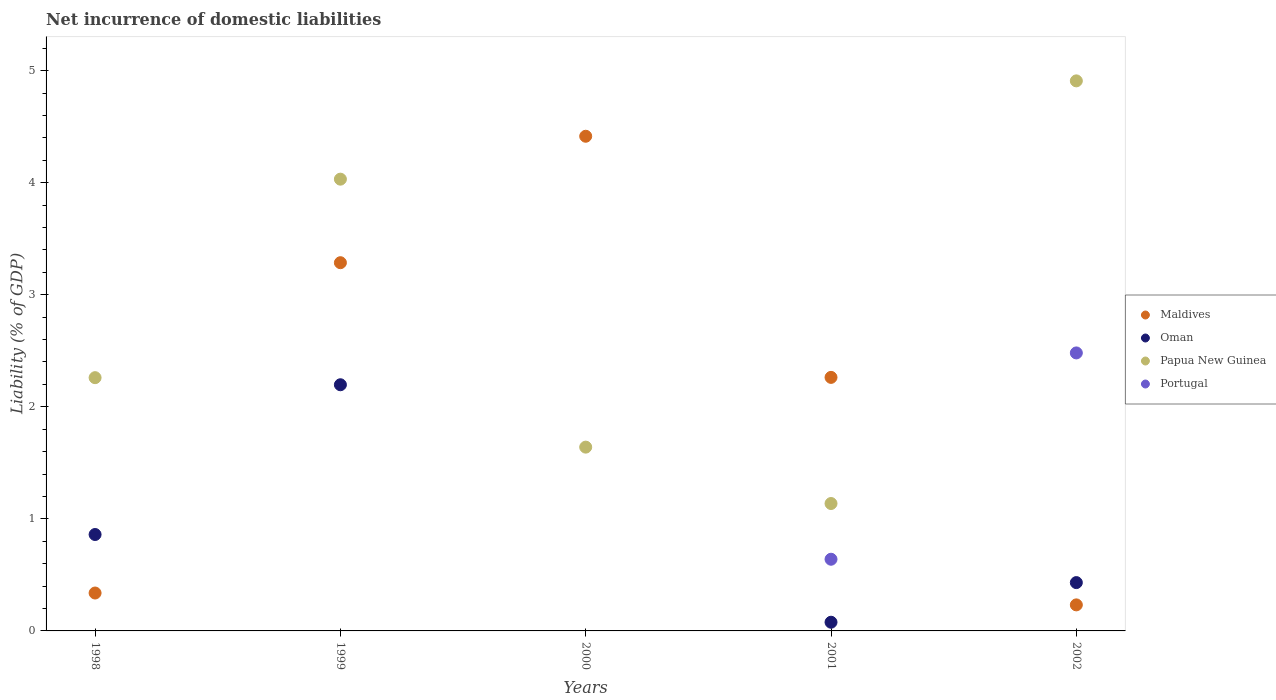How many different coloured dotlines are there?
Make the answer very short. 4. Across all years, what is the maximum net incurrence of domestic liabilities in Papua New Guinea?
Offer a very short reply. 4.91. Across all years, what is the minimum net incurrence of domestic liabilities in Papua New Guinea?
Ensure brevity in your answer.  1.14. In which year was the net incurrence of domestic liabilities in Maldives maximum?
Offer a terse response. 2000. What is the total net incurrence of domestic liabilities in Maldives in the graph?
Keep it short and to the point. 10.53. What is the difference between the net incurrence of domestic liabilities in Maldives in 2000 and that in 2002?
Offer a terse response. 4.18. What is the difference between the net incurrence of domestic liabilities in Papua New Guinea in 2002 and the net incurrence of domestic liabilities in Portugal in 2001?
Provide a short and direct response. 4.27. What is the average net incurrence of domestic liabilities in Maldives per year?
Offer a terse response. 2.11. In the year 2001, what is the difference between the net incurrence of domestic liabilities in Portugal and net incurrence of domestic liabilities in Oman?
Keep it short and to the point. 0.56. In how many years, is the net incurrence of domestic liabilities in Papua New Guinea greater than 4.8 %?
Your response must be concise. 1. What is the ratio of the net incurrence of domestic liabilities in Maldives in 1998 to that in 2000?
Provide a short and direct response. 0.08. Is the net incurrence of domestic liabilities in Oman in 1998 less than that in 2002?
Provide a short and direct response. No. What is the difference between the highest and the second highest net incurrence of domestic liabilities in Oman?
Your response must be concise. 1.34. What is the difference between the highest and the lowest net incurrence of domestic liabilities in Maldives?
Provide a succinct answer. 4.18. In how many years, is the net incurrence of domestic liabilities in Portugal greater than the average net incurrence of domestic liabilities in Portugal taken over all years?
Your response must be concise. 2. Does the net incurrence of domestic liabilities in Portugal monotonically increase over the years?
Offer a terse response. No. Does the graph contain any zero values?
Your answer should be very brief. Yes. How many legend labels are there?
Your answer should be very brief. 4. What is the title of the graph?
Provide a short and direct response. Net incurrence of domestic liabilities. Does "Chad" appear as one of the legend labels in the graph?
Your answer should be very brief. No. What is the label or title of the Y-axis?
Provide a short and direct response. Liability (% of GDP). What is the Liability (% of GDP) of Maldives in 1998?
Your answer should be very brief. 0.34. What is the Liability (% of GDP) of Oman in 1998?
Your answer should be compact. 0.86. What is the Liability (% of GDP) in Papua New Guinea in 1998?
Make the answer very short. 2.26. What is the Liability (% of GDP) of Maldives in 1999?
Ensure brevity in your answer.  3.29. What is the Liability (% of GDP) in Oman in 1999?
Give a very brief answer. 2.2. What is the Liability (% of GDP) of Papua New Guinea in 1999?
Make the answer very short. 4.03. What is the Liability (% of GDP) of Portugal in 1999?
Keep it short and to the point. 0. What is the Liability (% of GDP) in Maldives in 2000?
Your answer should be compact. 4.41. What is the Liability (% of GDP) of Papua New Guinea in 2000?
Keep it short and to the point. 1.64. What is the Liability (% of GDP) in Portugal in 2000?
Keep it short and to the point. 0. What is the Liability (% of GDP) of Maldives in 2001?
Your response must be concise. 2.26. What is the Liability (% of GDP) of Oman in 2001?
Your response must be concise. 0.08. What is the Liability (% of GDP) of Papua New Guinea in 2001?
Provide a succinct answer. 1.14. What is the Liability (% of GDP) in Portugal in 2001?
Your answer should be very brief. 0.64. What is the Liability (% of GDP) of Maldives in 2002?
Provide a short and direct response. 0.23. What is the Liability (% of GDP) in Oman in 2002?
Offer a very short reply. 0.43. What is the Liability (% of GDP) of Papua New Guinea in 2002?
Offer a very short reply. 4.91. What is the Liability (% of GDP) of Portugal in 2002?
Ensure brevity in your answer.  2.48. Across all years, what is the maximum Liability (% of GDP) of Maldives?
Make the answer very short. 4.41. Across all years, what is the maximum Liability (% of GDP) of Oman?
Your answer should be compact. 2.2. Across all years, what is the maximum Liability (% of GDP) of Papua New Guinea?
Keep it short and to the point. 4.91. Across all years, what is the maximum Liability (% of GDP) of Portugal?
Ensure brevity in your answer.  2.48. Across all years, what is the minimum Liability (% of GDP) in Maldives?
Your answer should be compact. 0.23. Across all years, what is the minimum Liability (% of GDP) of Papua New Guinea?
Your answer should be compact. 1.14. Across all years, what is the minimum Liability (% of GDP) of Portugal?
Your answer should be compact. 0. What is the total Liability (% of GDP) of Maldives in the graph?
Ensure brevity in your answer.  10.53. What is the total Liability (% of GDP) in Oman in the graph?
Give a very brief answer. 3.57. What is the total Liability (% of GDP) of Papua New Guinea in the graph?
Offer a very short reply. 13.98. What is the total Liability (% of GDP) in Portugal in the graph?
Ensure brevity in your answer.  3.12. What is the difference between the Liability (% of GDP) of Maldives in 1998 and that in 1999?
Your answer should be very brief. -2.95. What is the difference between the Liability (% of GDP) of Oman in 1998 and that in 1999?
Provide a succinct answer. -1.34. What is the difference between the Liability (% of GDP) of Papua New Guinea in 1998 and that in 1999?
Offer a very short reply. -1.77. What is the difference between the Liability (% of GDP) in Maldives in 1998 and that in 2000?
Make the answer very short. -4.08. What is the difference between the Liability (% of GDP) in Papua New Guinea in 1998 and that in 2000?
Make the answer very short. 0.62. What is the difference between the Liability (% of GDP) in Maldives in 1998 and that in 2001?
Your answer should be compact. -1.92. What is the difference between the Liability (% of GDP) in Oman in 1998 and that in 2001?
Offer a very short reply. 0.78. What is the difference between the Liability (% of GDP) of Papua New Guinea in 1998 and that in 2001?
Ensure brevity in your answer.  1.12. What is the difference between the Liability (% of GDP) in Maldives in 1998 and that in 2002?
Offer a very short reply. 0.11. What is the difference between the Liability (% of GDP) of Oman in 1998 and that in 2002?
Your response must be concise. 0.43. What is the difference between the Liability (% of GDP) in Papua New Guinea in 1998 and that in 2002?
Make the answer very short. -2.65. What is the difference between the Liability (% of GDP) in Maldives in 1999 and that in 2000?
Offer a terse response. -1.13. What is the difference between the Liability (% of GDP) in Papua New Guinea in 1999 and that in 2000?
Offer a terse response. 2.39. What is the difference between the Liability (% of GDP) in Maldives in 1999 and that in 2001?
Ensure brevity in your answer.  1.02. What is the difference between the Liability (% of GDP) of Oman in 1999 and that in 2001?
Ensure brevity in your answer.  2.12. What is the difference between the Liability (% of GDP) in Papua New Guinea in 1999 and that in 2001?
Provide a short and direct response. 2.89. What is the difference between the Liability (% of GDP) in Maldives in 1999 and that in 2002?
Make the answer very short. 3.05. What is the difference between the Liability (% of GDP) of Oman in 1999 and that in 2002?
Offer a very short reply. 1.77. What is the difference between the Liability (% of GDP) in Papua New Guinea in 1999 and that in 2002?
Provide a short and direct response. -0.88. What is the difference between the Liability (% of GDP) in Maldives in 2000 and that in 2001?
Offer a very short reply. 2.15. What is the difference between the Liability (% of GDP) in Papua New Guinea in 2000 and that in 2001?
Make the answer very short. 0.5. What is the difference between the Liability (% of GDP) of Maldives in 2000 and that in 2002?
Your answer should be very brief. 4.18. What is the difference between the Liability (% of GDP) in Papua New Guinea in 2000 and that in 2002?
Ensure brevity in your answer.  -3.27. What is the difference between the Liability (% of GDP) of Maldives in 2001 and that in 2002?
Your response must be concise. 2.03. What is the difference between the Liability (% of GDP) of Oman in 2001 and that in 2002?
Make the answer very short. -0.35. What is the difference between the Liability (% of GDP) in Papua New Guinea in 2001 and that in 2002?
Ensure brevity in your answer.  -3.77. What is the difference between the Liability (% of GDP) of Portugal in 2001 and that in 2002?
Your response must be concise. -1.84. What is the difference between the Liability (% of GDP) of Maldives in 1998 and the Liability (% of GDP) of Oman in 1999?
Keep it short and to the point. -1.86. What is the difference between the Liability (% of GDP) of Maldives in 1998 and the Liability (% of GDP) of Papua New Guinea in 1999?
Your answer should be very brief. -3.69. What is the difference between the Liability (% of GDP) in Oman in 1998 and the Liability (% of GDP) in Papua New Guinea in 1999?
Your answer should be very brief. -3.17. What is the difference between the Liability (% of GDP) of Maldives in 1998 and the Liability (% of GDP) of Papua New Guinea in 2000?
Offer a very short reply. -1.3. What is the difference between the Liability (% of GDP) of Oman in 1998 and the Liability (% of GDP) of Papua New Guinea in 2000?
Provide a short and direct response. -0.78. What is the difference between the Liability (% of GDP) in Maldives in 1998 and the Liability (% of GDP) in Oman in 2001?
Your response must be concise. 0.26. What is the difference between the Liability (% of GDP) of Maldives in 1998 and the Liability (% of GDP) of Papua New Guinea in 2001?
Your answer should be compact. -0.8. What is the difference between the Liability (% of GDP) in Maldives in 1998 and the Liability (% of GDP) in Portugal in 2001?
Your answer should be very brief. -0.3. What is the difference between the Liability (% of GDP) in Oman in 1998 and the Liability (% of GDP) in Papua New Guinea in 2001?
Keep it short and to the point. -0.28. What is the difference between the Liability (% of GDP) of Oman in 1998 and the Liability (% of GDP) of Portugal in 2001?
Offer a terse response. 0.22. What is the difference between the Liability (% of GDP) of Papua New Guinea in 1998 and the Liability (% of GDP) of Portugal in 2001?
Make the answer very short. 1.62. What is the difference between the Liability (% of GDP) of Maldives in 1998 and the Liability (% of GDP) of Oman in 2002?
Provide a short and direct response. -0.09. What is the difference between the Liability (% of GDP) of Maldives in 1998 and the Liability (% of GDP) of Papua New Guinea in 2002?
Your response must be concise. -4.57. What is the difference between the Liability (% of GDP) of Maldives in 1998 and the Liability (% of GDP) of Portugal in 2002?
Give a very brief answer. -2.14. What is the difference between the Liability (% of GDP) of Oman in 1998 and the Liability (% of GDP) of Papua New Guinea in 2002?
Give a very brief answer. -4.05. What is the difference between the Liability (% of GDP) of Oman in 1998 and the Liability (% of GDP) of Portugal in 2002?
Make the answer very short. -1.62. What is the difference between the Liability (% of GDP) of Papua New Guinea in 1998 and the Liability (% of GDP) of Portugal in 2002?
Give a very brief answer. -0.22. What is the difference between the Liability (% of GDP) in Maldives in 1999 and the Liability (% of GDP) in Papua New Guinea in 2000?
Your response must be concise. 1.65. What is the difference between the Liability (% of GDP) of Oman in 1999 and the Liability (% of GDP) of Papua New Guinea in 2000?
Your response must be concise. 0.56. What is the difference between the Liability (% of GDP) in Maldives in 1999 and the Liability (% of GDP) in Oman in 2001?
Give a very brief answer. 3.21. What is the difference between the Liability (% of GDP) of Maldives in 1999 and the Liability (% of GDP) of Papua New Guinea in 2001?
Your answer should be very brief. 2.15. What is the difference between the Liability (% of GDP) of Maldives in 1999 and the Liability (% of GDP) of Portugal in 2001?
Make the answer very short. 2.65. What is the difference between the Liability (% of GDP) in Oman in 1999 and the Liability (% of GDP) in Papua New Guinea in 2001?
Give a very brief answer. 1.06. What is the difference between the Liability (% of GDP) of Oman in 1999 and the Liability (% of GDP) of Portugal in 2001?
Your answer should be compact. 1.56. What is the difference between the Liability (% of GDP) of Papua New Guinea in 1999 and the Liability (% of GDP) of Portugal in 2001?
Your answer should be very brief. 3.39. What is the difference between the Liability (% of GDP) of Maldives in 1999 and the Liability (% of GDP) of Oman in 2002?
Your answer should be compact. 2.85. What is the difference between the Liability (% of GDP) of Maldives in 1999 and the Liability (% of GDP) of Papua New Guinea in 2002?
Provide a short and direct response. -1.62. What is the difference between the Liability (% of GDP) in Maldives in 1999 and the Liability (% of GDP) in Portugal in 2002?
Make the answer very short. 0.81. What is the difference between the Liability (% of GDP) in Oman in 1999 and the Liability (% of GDP) in Papua New Guinea in 2002?
Your answer should be compact. -2.71. What is the difference between the Liability (% of GDP) in Oman in 1999 and the Liability (% of GDP) in Portugal in 2002?
Make the answer very short. -0.28. What is the difference between the Liability (% of GDP) in Papua New Guinea in 1999 and the Liability (% of GDP) in Portugal in 2002?
Offer a very short reply. 1.55. What is the difference between the Liability (% of GDP) of Maldives in 2000 and the Liability (% of GDP) of Oman in 2001?
Make the answer very short. 4.34. What is the difference between the Liability (% of GDP) of Maldives in 2000 and the Liability (% of GDP) of Papua New Guinea in 2001?
Your answer should be compact. 3.28. What is the difference between the Liability (% of GDP) in Maldives in 2000 and the Liability (% of GDP) in Portugal in 2001?
Keep it short and to the point. 3.77. What is the difference between the Liability (% of GDP) of Maldives in 2000 and the Liability (% of GDP) of Oman in 2002?
Offer a very short reply. 3.98. What is the difference between the Liability (% of GDP) in Maldives in 2000 and the Liability (% of GDP) in Papua New Guinea in 2002?
Ensure brevity in your answer.  -0.49. What is the difference between the Liability (% of GDP) in Maldives in 2000 and the Liability (% of GDP) in Portugal in 2002?
Your answer should be very brief. 1.93. What is the difference between the Liability (% of GDP) of Papua New Guinea in 2000 and the Liability (% of GDP) of Portugal in 2002?
Give a very brief answer. -0.84. What is the difference between the Liability (% of GDP) in Maldives in 2001 and the Liability (% of GDP) in Oman in 2002?
Provide a short and direct response. 1.83. What is the difference between the Liability (% of GDP) in Maldives in 2001 and the Liability (% of GDP) in Papua New Guinea in 2002?
Provide a short and direct response. -2.65. What is the difference between the Liability (% of GDP) in Maldives in 2001 and the Liability (% of GDP) in Portugal in 2002?
Your answer should be very brief. -0.22. What is the difference between the Liability (% of GDP) in Oman in 2001 and the Liability (% of GDP) in Papua New Guinea in 2002?
Your response must be concise. -4.83. What is the difference between the Liability (% of GDP) in Oman in 2001 and the Liability (% of GDP) in Portugal in 2002?
Give a very brief answer. -2.4. What is the difference between the Liability (% of GDP) of Papua New Guinea in 2001 and the Liability (% of GDP) of Portugal in 2002?
Provide a short and direct response. -1.34. What is the average Liability (% of GDP) in Maldives per year?
Your answer should be compact. 2.11. What is the average Liability (% of GDP) in Oman per year?
Offer a very short reply. 0.71. What is the average Liability (% of GDP) of Papua New Guinea per year?
Give a very brief answer. 2.8. What is the average Liability (% of GDP) in Portugal per year?
Provide a succinct answer. 0.62. In the year 1998, what is the difference between the Liability (% of GDP) of Maldives and Liability (% of GDP) of Oman?
Offer a very short reply. -0.52. In the year 1998, what is the difference between the Liability (% of GDP) of Maldives and Liability (% of GDP) of Papua New Guinea?
Keep it short and to the point. -1.92. In the year 1998, what is the difference between the Liability (% of GDP) in Oman and Liability (% of GDP) in Papua New Guinea?
Provide a short and direct response. -1.4. In the year 1999, what is the difference between the Liability (% of GDP) in Maldives and Liability (% of GDP) in Oman?
Make the answer very short. 1.09. In the year 1999, what is the difference between the Liability (% of GDP) in Maldives and Liability (% of GDP) in Papua New Guinea?
Your response must be concise. -0.75. In the year 1999, what is the difference between the Liability (% of GDP) in Oman and Liability (% of GDP) in Papua New Guinea?
Offer a terse response. -1.83. In the year 2000, what is the difference between the Liability (% of GDP) in Maldives and Liability (% of GDP) in Papua New Guinea?
Ensure brevity in your answer.  2.77. In the year 2001, what is the difference between the Liability (% of GDP) of Maldives and Liability (% of GDP) of Oman?
Offer a terse response. 2.19. In the year 2001, what is the difference between the Liability (% of GDP) in Maldives and Liability (% of GDP) in Papua New Guinea?
Provide a short and direct response. 1.13. In the year 2001, what is the difference between the Liability (% of GDP) of Maldives and Liability (% of GDP) of Portugal?
Ensure brevity in your answer.  1.62. In the year 2001, what is the difference between the Liability (% of GDP) of Oman and Liability (% of GDP) of Papua New Guinea?
Give a very brief answer. -1.06. In the year 2001, what is the difference between the Liability (% of GDP) in Oman and Liability (% of GDP) in Portugal?
Provide a short and direct response. -0.56. In the year 2001, what is the difference between the Liability (% of GDP) of Papua New Guinea and Liability (% of GDP) of Portugal?
Your answer should be compact. 0.5. In the year 2002, what is the difference between the Liability (% of GDP) of Maldives and Liability (% of GDP) of Oman?
Offer a terse response. -0.2. In the year 2002, what is the difference between the Liability (% of GDP) of Maldives and Liability (% of GDP) of Papua New Guinea?
Offer a very short reply. -4.68. In the year 2002, what is the difference between the Liability (% of GDP) of Maldives and Liability (% of GDP) of Portugal?
Give a very brief answer. -2.25. In the year 2002, what is the difference between the Liability (% of GDP) of Oman and Liability (% of GDP) of Papua New Guinea?
Provide a short and direct response. -4.48. In the year 2002, what is the difference between the Liability (% of GDP) of Oman and Liability (% of GDP) of Portugal?
Your answer should be compact. -2.05. In the year 2002, what is the difference between the Liability (% of GDP) in Papua New Guinea and Liability (% of GDP) in Portugal?
Your response must be concise. 2.43. What is the ratio of the Liability (% of GDP) in Maldives in 1998 to that in 1999?
Make the answer very short. 0.1. What is the ratio of the Liability (% of GDP) in Oman in 1998 to that in 1999?
Your answer should be compact. 0.39. What is the ratio of the Liability (% of GDP) of Papua New Guinea in 1998 to that in 1999?
Your answer should be very brief. 0.56. What is the ratio of the Liability (% of GDP) in Maldives in 1998 to that in 2000?
Your answer should be compact. 0.08. What is the ratio of the Liability (% of GDP) of Papua New Guinea in 1998 to that in 2000?
Give a very brief answer. 1.38. What is the ratio of the Liability (% of GDP) of Maldives in 1998 to that in 2001?
Provide a short and direct response. 0.15. What is the ratio of the Liability (% of GDP) of Oman in 1998 to that in 2001?
Your answer should be compact. 11.1. What is the ratio of the Liability (% of GDP) in Papua New Guinea in 1998 to that in 2001?
Ensure brevity in your answer.  1.99. What is the ratio of the Liability (% of GDP) of Maldives in 1998 to that in 2002?
Make the answer very short. 1.46. What is the ratio of the Liability (% of GDP) in Oman in 1998 to that in 2002?
Offer a very short reply. 2. What is the ratio of the Liability (% of GDP) in Papua New Guinea in 1998 to that in 2002?
Your answer should be compact. 0.46. What is the ratio of the Liability (% of GDP) of Maldives in 1999 to that in 2000?
Provide a short and direct response. 0.74. What is the ratio of the Liability (% of GDP) of Papua New Guinea in 1999 to that in 2000?
Offer a very short reply. 2.46. What is the ratio of the Liability (% of GDP) in Maldives in 1999 to that in 2001?
Offer a terse response. 1.45. What is the ratio of the Liability (% of GDP) of Oman in 1999 to that in 2001?
Make the answer very short. 28.33. What is the ratio of the Liability (% of GDP) in Papua New Guinea in 1999 to that in 2001?
Make the answer very short. 3.55. What is the ratio of the Liability (% of GDP) of Maldives in 1999 to that in 2002?
Your answer should be very brief. 14.14. What is the ratio of the Liability (% of GDP) of Oman in 1999 to that in 2002?
Offer a terse response. 5.09. What is the ratio of the Liability (% of GDP) of Papua New Guinea in 1999 to that in 2002?
Keep it short and to the point. 0.82. What is the ratio of the Liability (% of GDP) in Maldives in 2000 to that in 2001?
Give a very brief answer. 1.95. What is the ratio of the Liability (% of GDP) in Papua New Guinea in 2000 to that in 2001?
Your answer should be compact. 1.44. What is the ratio of the Liability (% of GDP) of Maldives in 2000 to that in 2002?
Ensure brevity in your answer.  18.99. What is the ratio of the Liability (% of GDP) of Papua New Guinea in 2000 to that in 2002?
Offer a very short reply. 0.33. What is the ratio of the Liability (% of GDP) in Maldives in 2001 to that in 2002?
Your answer should be compact. 9.73. What is the ratio of the Liability (% of GDP) of Oman in 2001 to that in 2002?
Make the answer very short. 0.18. What is the ratio of the Liability (% of GDP) of Papua New Guinea in 2001 to that in 2002?
Provide a short and direct response. 0.23. What is the ratio of the Liability (% of GDP) in Portugal in 2001 to that in 2002?
Provide a short and direct response. 0.26. What is the difference between the highest and the second highest Liability (% of GDP) of Maldives?
Give a very brief answer. 1.13. What is the difference between the highest and the second highest Liability (% of GDP) of Oman?
Provide a succinct answer. 1.34. What is the difference between the highest and the second highest Liability (% of GDP) of Papua New Guinea?
Your answer should be very brief. 0.88. What is the difference between the highest and the lowest Liability (% of GDP) of Maldives?
Ensure brevity in your answer.  4.18. What is the difference between the highest and the lowest Liability (% of GDP) of Oman?
Make the answer very short. 2.2. What is the difference between the highest and the lowest Liability (% of GDP) of Papua New Guinea?
Your response must be concise. 3.77. What is the difference between the highest and the lowest Liability (% of GDP) of Portugal?
Ensure brevity in your answer.  2.48. 